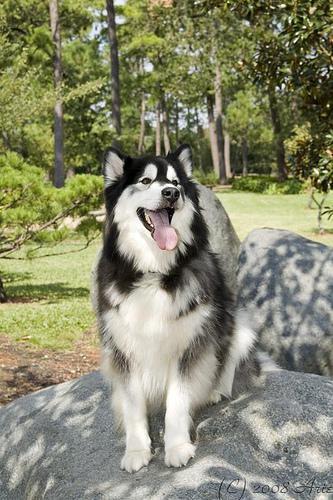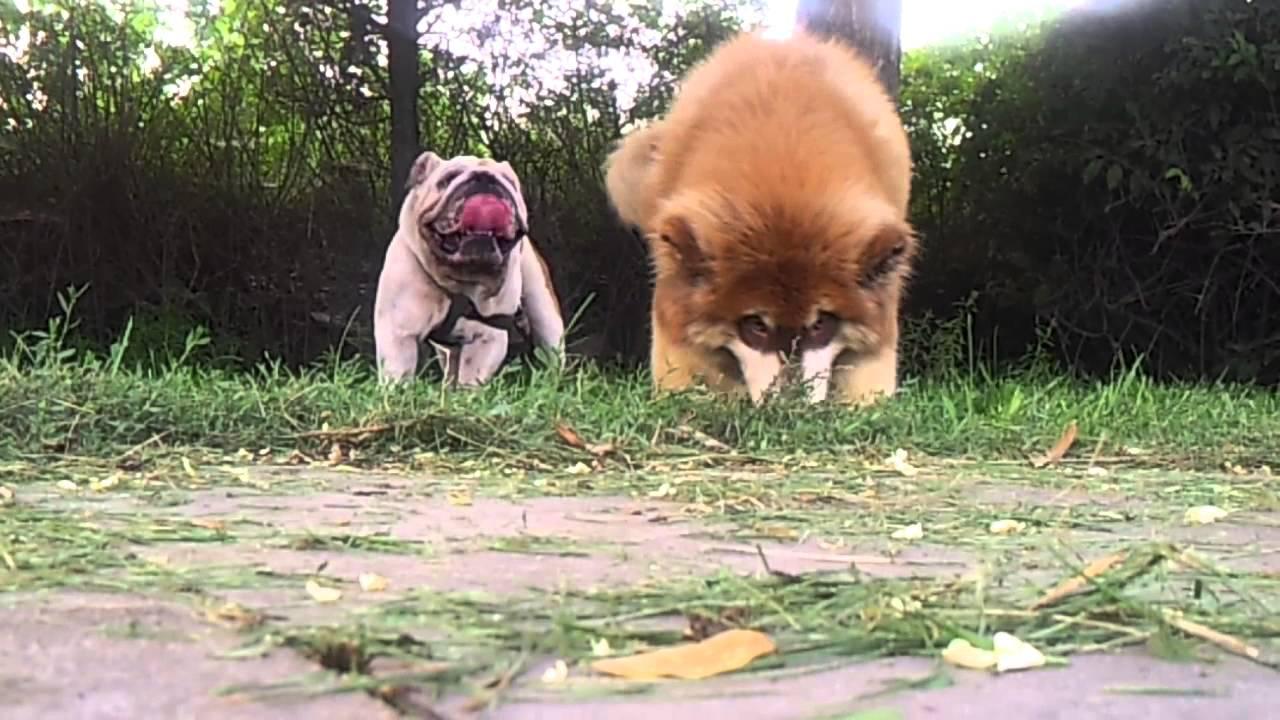The first image is the image on the left, the second image is the image on the right. For the images shown, is this caption "There are only two dogs." true? Answer yes or no. No. The first image is the image on the left, the second image is the image on the right. Analyze the images presented: Is the assertion "No image contains more than one dog, all dogs are husky-type, and the image on the left shows a dog standing on all fours." valid? Answer yes or no. No. 